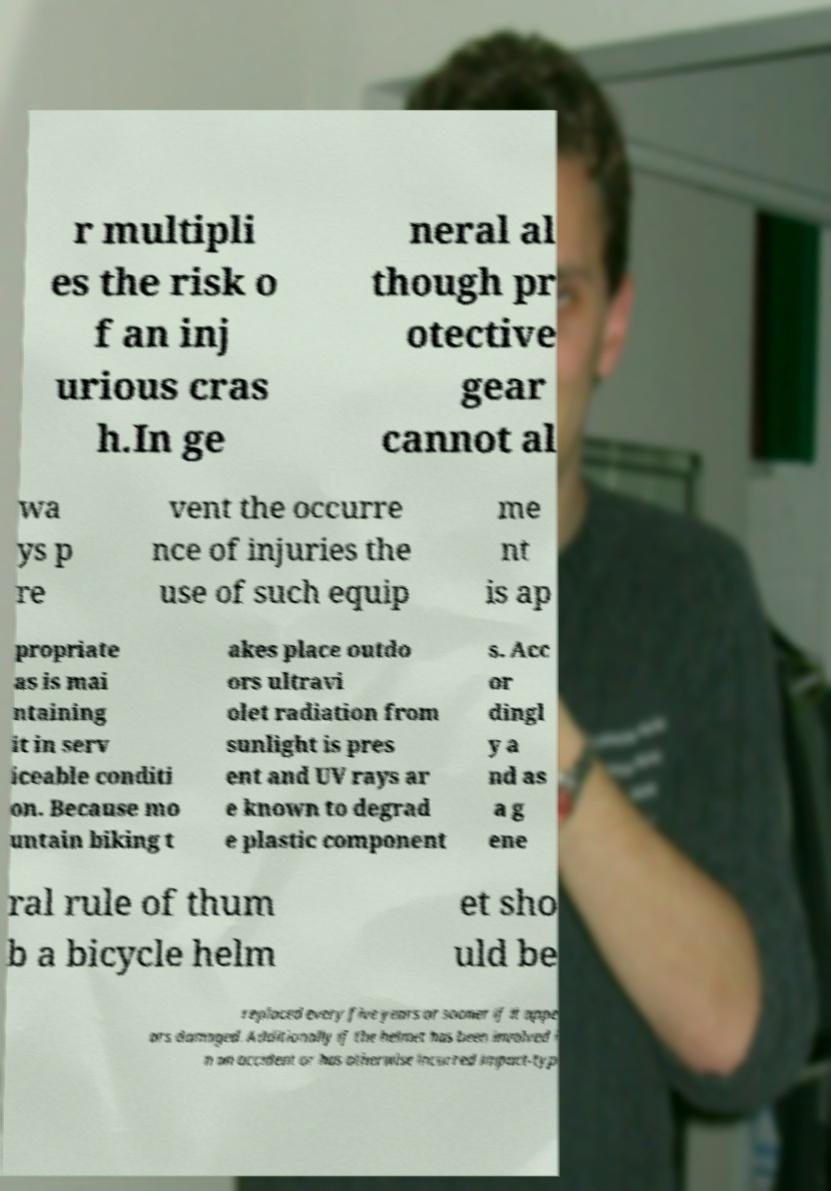Please identify and transcribe the text found in this image. r multipli es the risk o f an inj urious cras h.In ge neral al though pr otective gear cannot al wa ys p re vent the occurre nce of injuries the use of such equip me nt is ap propriate as is mai ntaining it in serv iceable conditi on. Because mo untain biking t akes place outdo ors ultravi olet radiation from sunlight is pres ent and UV rays ar e known to degrad e plastic component s. Acc or dingl y a nd as a g ene ral rule of thum b a bicycle helm et sho uld be replaced every five years or sooner if it appe ars damaged. Additionally if the helmet has been involved i n an accident or has otherwise incurred impact-typ 